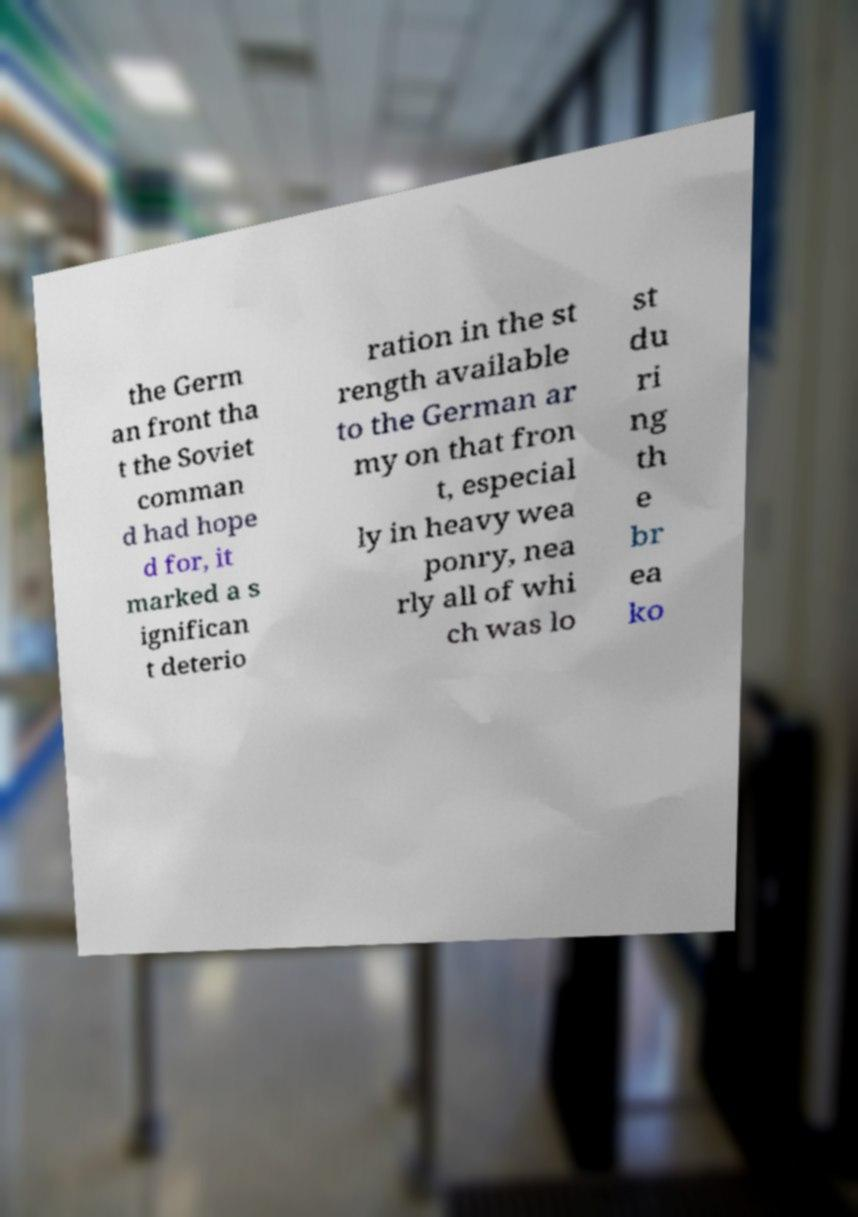What messages or text are displayed in this image? I need them in a readable, typed format. the Germ an front tha t the Soviet comman d had hope d for, it marked a s ignifican t deterio ration in the st rength available to the German ar my on that fron t, especial ly in heavy wea ponry, nea rly all of whi ch was lo st du ri ng th e br ea ko 